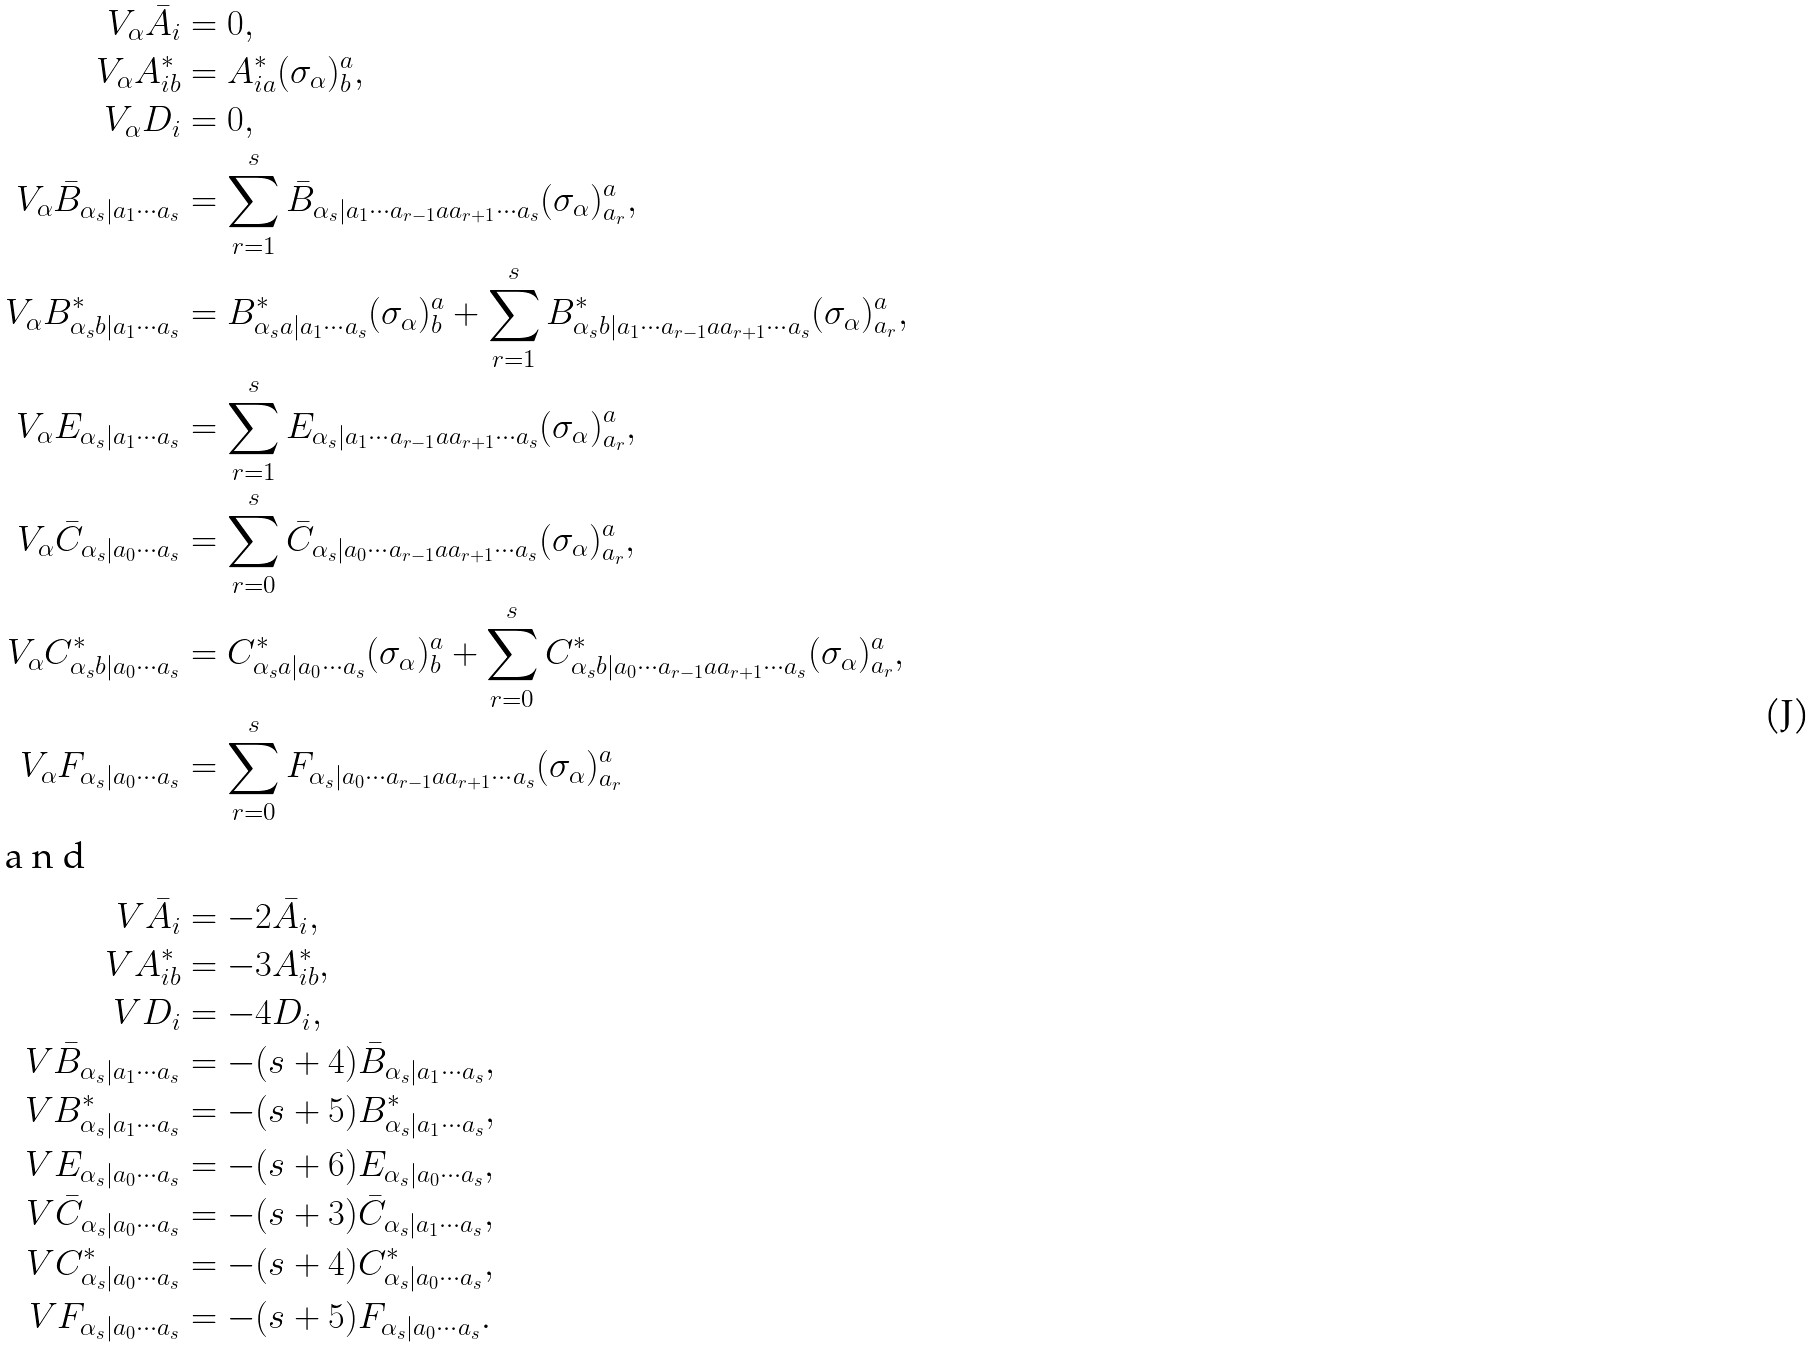<formula> <loc_0><loc_0><loc_500><loc_500>V _ { \alpha } \bar { A } _ { i } & = 0 , \\ V _ { \alpha } A _ { i b } ^ { * } & = A _ { i a } ^ { * } ( \sigma _ { \alpha } ) ^ { a } _ { b } , \\ V _ { \alpha } D _ { i } & = 0 , \\ V _ { \alpha } \bar { B } _ { \alpha _ { s } | a _ { 1 } \cdots a _ { s } } & = \sum _ { r = 1 } ^ { s } \bar { B } _ { \alpha _ { s } | a _ { 1 } \cdots a _ { r - 1 } a a _ { r + 1 } \cdots a _ { s } } ( \sigma _ { \alpha } ) ^ { a } _ { a _ { r } } , \\ V _ { \alpha } B _ { \alpha _ { s } b | a _ { 1 } \cdots a _ { s } } ^ { * } & = B _ { \alpha _ { s } a | a _ { 1 } \cdots a _ { s } } ^ { * } ( \sigma _ { \alpha } ) ^ { a } _ { b } + \sum _ { r = 1 } ^ { s } B _ { \alpha _ { s } b | a _ { 1 } \cdots a _ { r - 1 } a a _ { r + 1 } \cdots a _ { s } } ^ { * } ( \sigma _ { \alpha } ) ^ { a } _ { a _ { r } } , \\ V _ { \alpha } E _ { \alpha _ { s } | a _ { 1 } \cdots a _ { s } } & = \sum _ { r = 1 } ^ { s } E _ { \alpha _ { s } | a _ { 1 } \cdots a _ { r - 1 } a a _ { r + 1 } \cdots a _ { s } } ( \sigma _ { \alpha } ) ^ { a } _ { a _ { r } } , \\ V _ { \alpha } \bar { C } _ { \alpha _ { s } | a _ { 0 } \cdots a _ { s } } & = \sum _ { r = 0 } ^ { s } \bar { C } _ { \alpha _ { s } | a _ { 0 } \cdots a _ { r - 1 } a a _ { r + 1 } \cdots a _ { s } } ( \sigma _ { \alpha } ) ^ { a } _ { a _ { r } } , \\ V _ { \alpha } C _ { \alpha _ { s } b | a _ { 0 } \cdots a _ { s } } ^ { * } & = C _ { \alpha _ { s } a | a _ { 0 } \cdots a _ { s } } ^ { * } ( \sigma _ { \alpha } ) ^ { a } _ { b } + \sum _ { r = 0 } ^ { s } C _ { \alpha _ { s } b | a _ { 0 } \cdots a _ { r - 1 } a a _ { r + 1 } \cdots a _ { s } } ^ { * } ( \sigma _ { \alpha } ) ^ { a } _ { a _ { r } } , \\ V _ { \alpha } F _ { \alpha _ { s } | a _ { 0 } \cdots a _ { s } } & = \sum _ { r = 0 } ^ { s } F _ { \alpha _ { s } | a _ { 0 } \cdots a _ { r - 1 } a a _ { r + 1 } \cdots a _ { s } } ( \sigma _ { \alpha } ) ^ { a } _ { a _ { r } } \\ \intertext { a n d } V \bar { A } _ { i } & = - 2 \bar { A } _ { i } , \\ V A _ { i b } ^ { * } & = - 3 A _ { i b } ^ { * } , \\ V D _ { i } & = - 4 D _ { i } , \\ V \bar { B } _ { \alpha _ { s } | a _ { 1 } \cdots a _ { s } } & = - ( s + 4 ) \bar { B } _ { \alpha _ { s } | a _ { 1 } \cdots a _ { s } } , \\ V B _ { \alpha _ { s } | a _ { 1 } \cdots a _ { s } } ^ { * } & = - ( s + 5 ) B _ { \alpha _ { s } | a _ { 1 } \cdots a _ { s } } ^ { * } , \\ V E _ { \alpha _ { s } | a _ { 0 } \cdots a _ { s } } & = - ( s + 6 ) E _ { \alpha _ { s } | a _ { 0 } \cdots a _ { s } } , \\ V \bar { C } _ { \alpha _ { s } | a _ { 0 } \cdots a _ { s } } & = - ( s + 3 ) \bar { C } _ { \alpha _ { s } | a _ { 1 } \cdots a _ { s } } , \\ V C _ { \alpha _ { s } | a _ { 0 } \cdots a _ { s } } ^ { * } & = - ( s + 4 ) C _ { \alpha _ { s } | a _ { 0 } \cdots a _ { s } } ^ { * } , \\ V F _ { \alpha _ { s } | a _ { 0 } \cdots a _ { s } } & = - ( s + 5 ) F _ { \alpha _ { s } | a _ { 0 } \cdots a _ { s } } .</formula> 